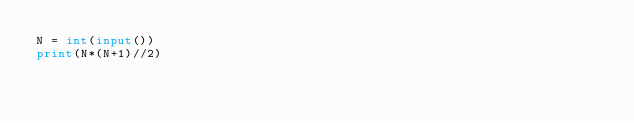<code> <loc_0><loc_0><loc_500><loc_500><_Python_>N = int(input())
print(N*(N+1)//2)</code> 